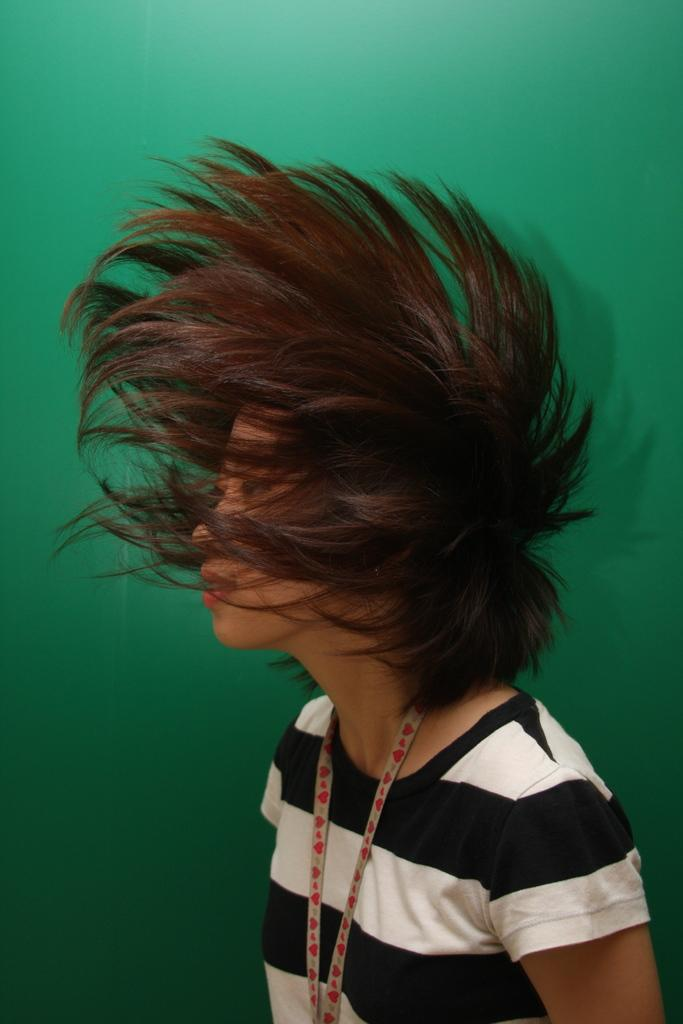What is present in the image? There is a person in the image. Can you describe the person's appearance in the image? The person's face is covered by their hair. What color is the background of the image? The background of the image is green in color. What time does the person's mother watch the sunset in the image? There is no information about a mother or a sunset in the image. What type of watch is the person wearing in the image? There is no watch visible on the person in the image. 